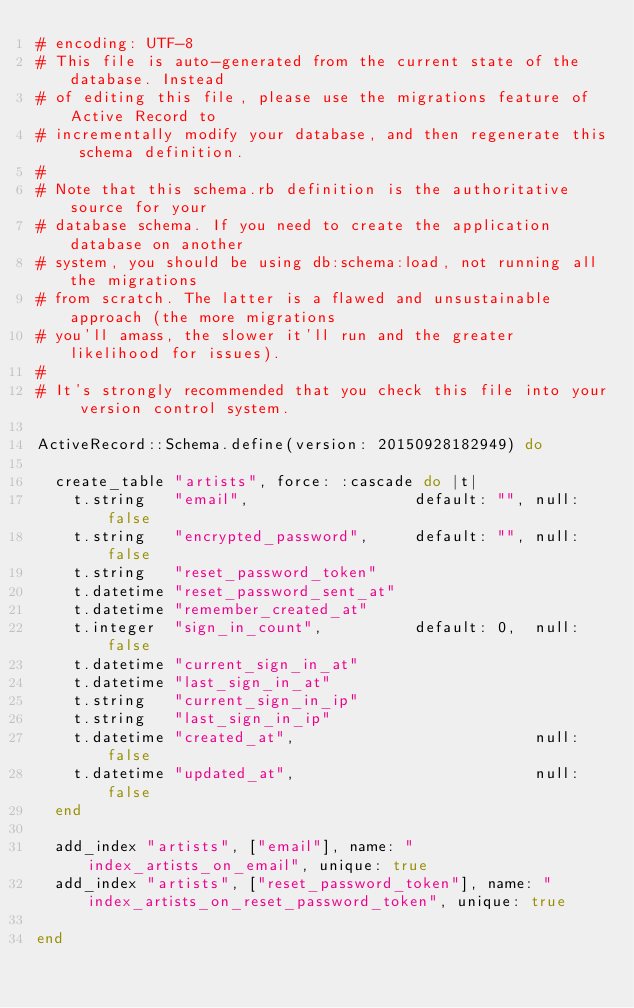Convert code to text. <code><loc_0><loc_0><loc_500><loc_500><_Ruby_># encoding: UTF-8
# This file is auto-generated from the current state of the database. Instead
# of editing this file, please use the migrations feature of Active Record to
# incrementally modify your database, and then regenerate this schema definition.
#
# Note that this schema.rb definition is the authoritative source for your
# database schema. If you need to create the application database on another
# system, you should be using db:schema:load, not running all the migrations
# from scratch. The latter is a flawed and unsustainable approach (the more migrations
# you'll amass, the slower it'll run and the greater likelihood for issues).
#
# It's strongly recommended that you check this file into your version control system.

ActiveRecord::Schema.define(version: 20150928182949) do

  create_table "artists", force: :cascade do |t|
    t.string   "email",                  default: "", null: false
    t.string   "encrypted_password",     default: "", null: false
    t.string   "reset_password_token"
    t.datetime "reset_password_sent_at"
    t.datetime "remember_created_at"
    t.integer  "sign_in_count",          default: 0,  null: false
    t.datetime "current_sign_in_at"
    t.datetime "last_sign_in_at"
    t.string   "current_sign_in_ip"
    t.string   "last_sign_in_ip"
    t.datetime "created_at",                          null: false
    t.datetime "updated_at",                          null: false
  end

  add_index "artists", ["email"], name: "index_artists_on_email", unique: true
  add_index "artists", ["reset_password_token"], name: "index_artists_on_reset_password_token", unique: true

end
</code> 